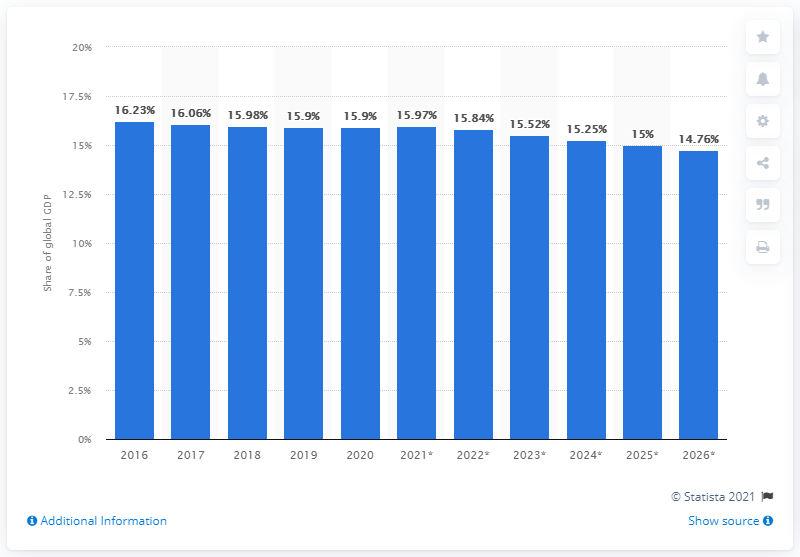Mention a couple of crucial points in this snapshot. In 2020, the United States accounted for approximately 15.84% of the global GDP. 